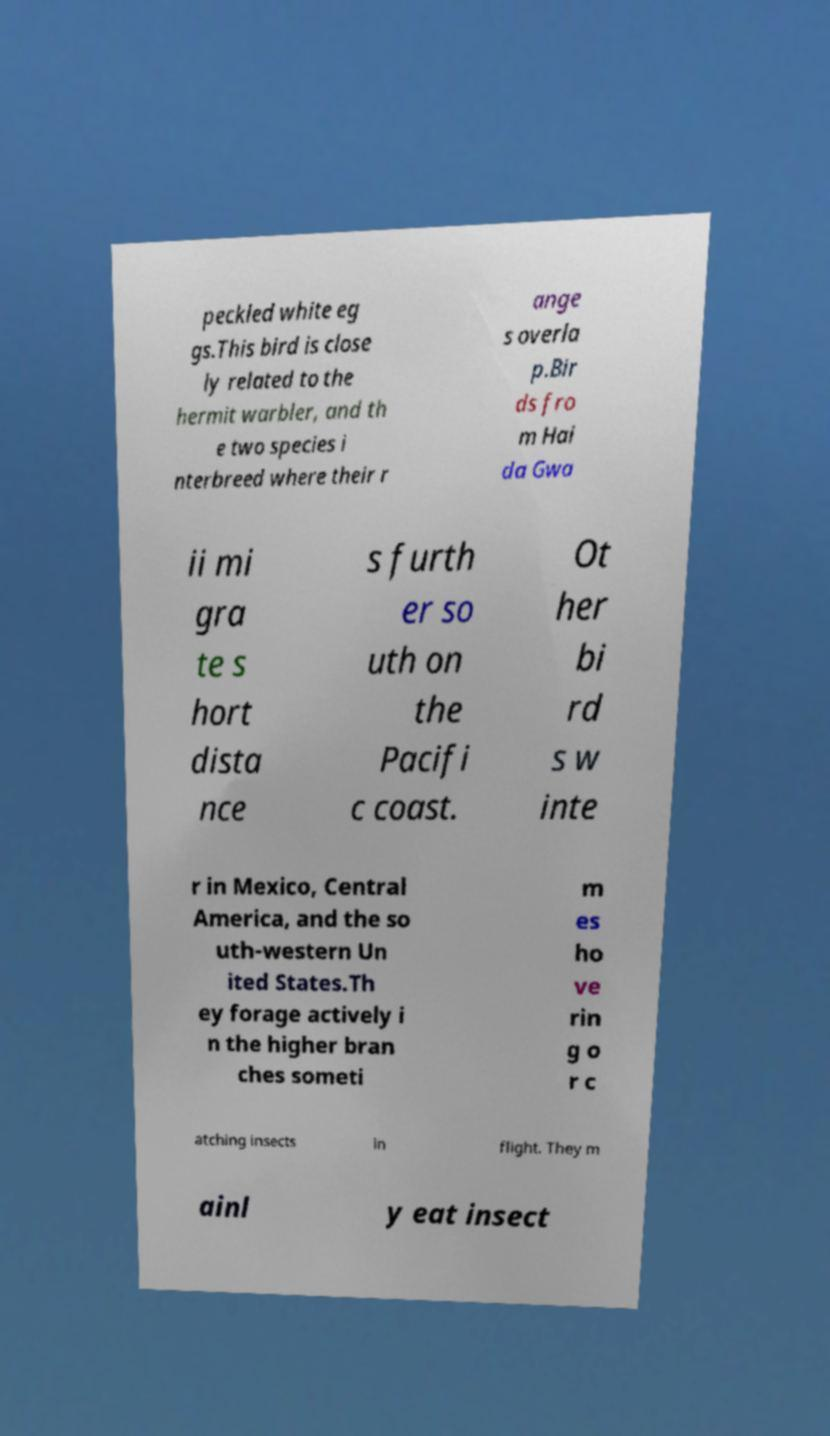Please read and relay the text visible in this image. What does it say? peckled white eg gs.This bird is close ly related to the hermit warbler, and th e two species i nterbreed where their r ange s overla p.Bir ds fro m Hai da Gwa ii mi gra te s hort dista nce s furth er so uth on the Pacifi c coast. Ot her bi rd s w inte r in Mexico, Central America, and the so uth-western Un ited States.Th ey forage actively i n the higher bran ches someti m es ho ve rin g o r c atching insects in flight. They m ainl y eat insect 